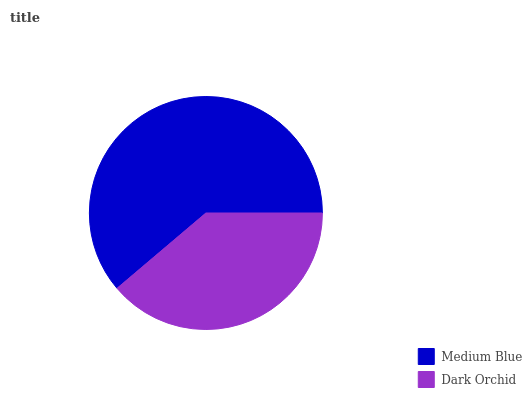Is Dark Orchid the minimum?
Answer yes or no. Yes. Is Medium Blue the maximum?
Answer yes or no. Yes. Is Dark Orchid the maximum?
Answer yes or no. No. Is Medium Blue greater than Dark Orchid?
Answer yes or no. Yes. Is Dark Orchid less than Medium Blue?
Answer yes or no. Yes. Is Dark Orchid greater than Medium Blue?
Answer yes or no. No. Is Medium Blue less than Dark Orchid?
Answer yes or no. No. Is Medium Blue the high median?
Answer yes or no. Yes. Is Dark Orchid the low median?
Answer yes or no. Yes. Is Dark Orchid the high median?
Answer yes or no. No. Is Medium Blue the low median?
Answer yes or no. No. 